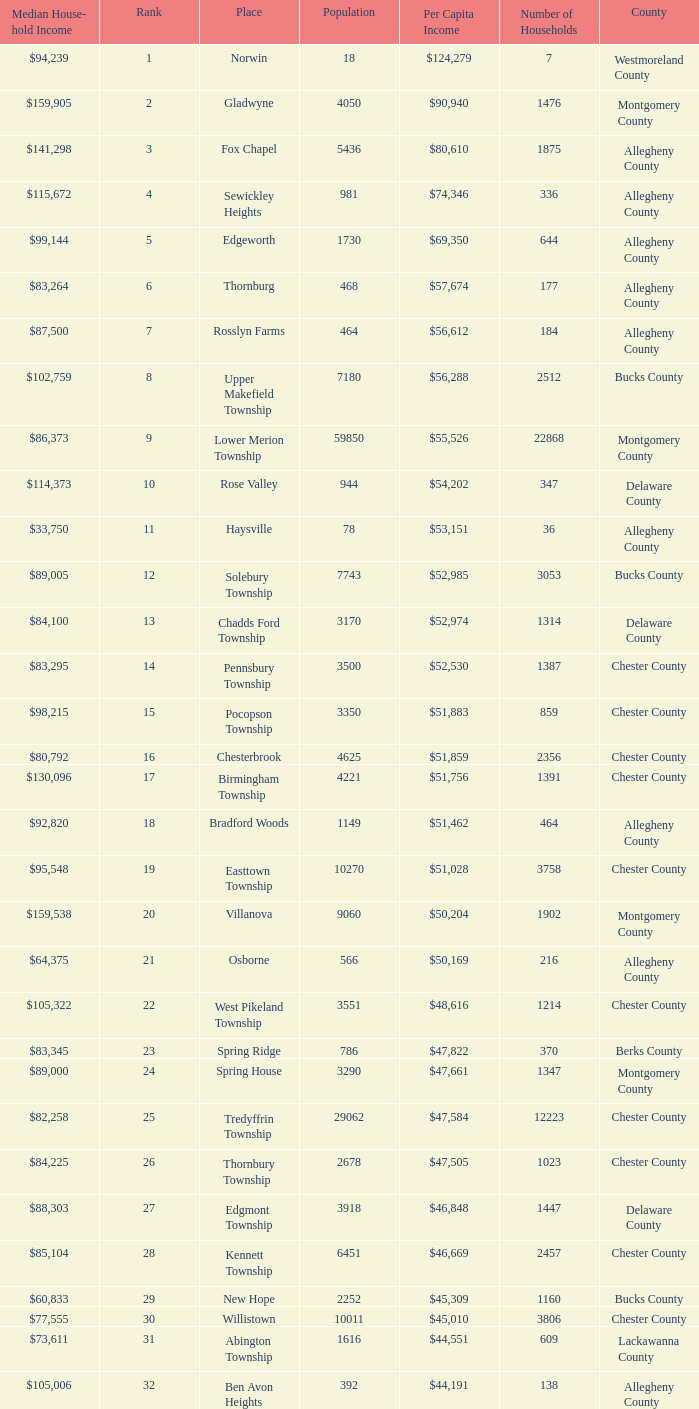Which county has a median household income of  $98,090? Bucks County. 